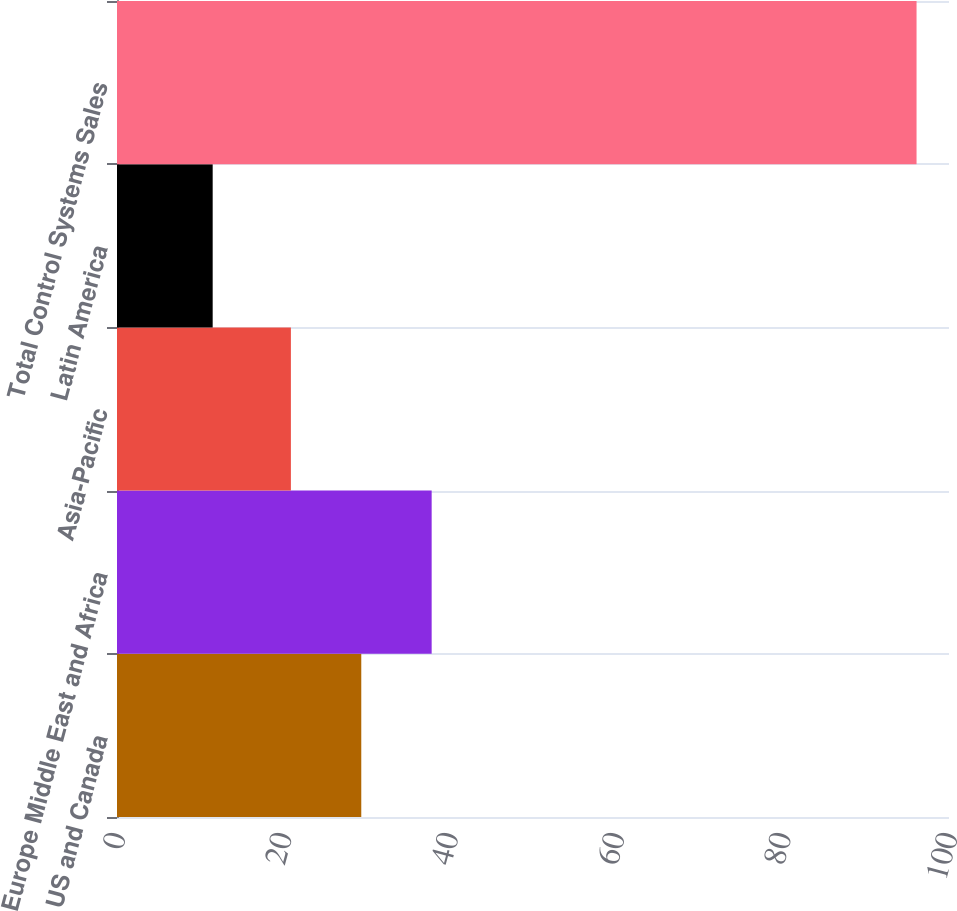<chart> <loc_0><loc_0><loc_500><loc_500><bar_chart><fcel>US and Canada<fcel>Europe Middle East and Africa<fcel>Asia-Pacific<fcel>Latin America<fcel>Total Control Systems Sales<nl><fcel>29.36<fcel>37.82<fcel>20.9<fcel>11.5<fcel>96.1<nl></chart> 